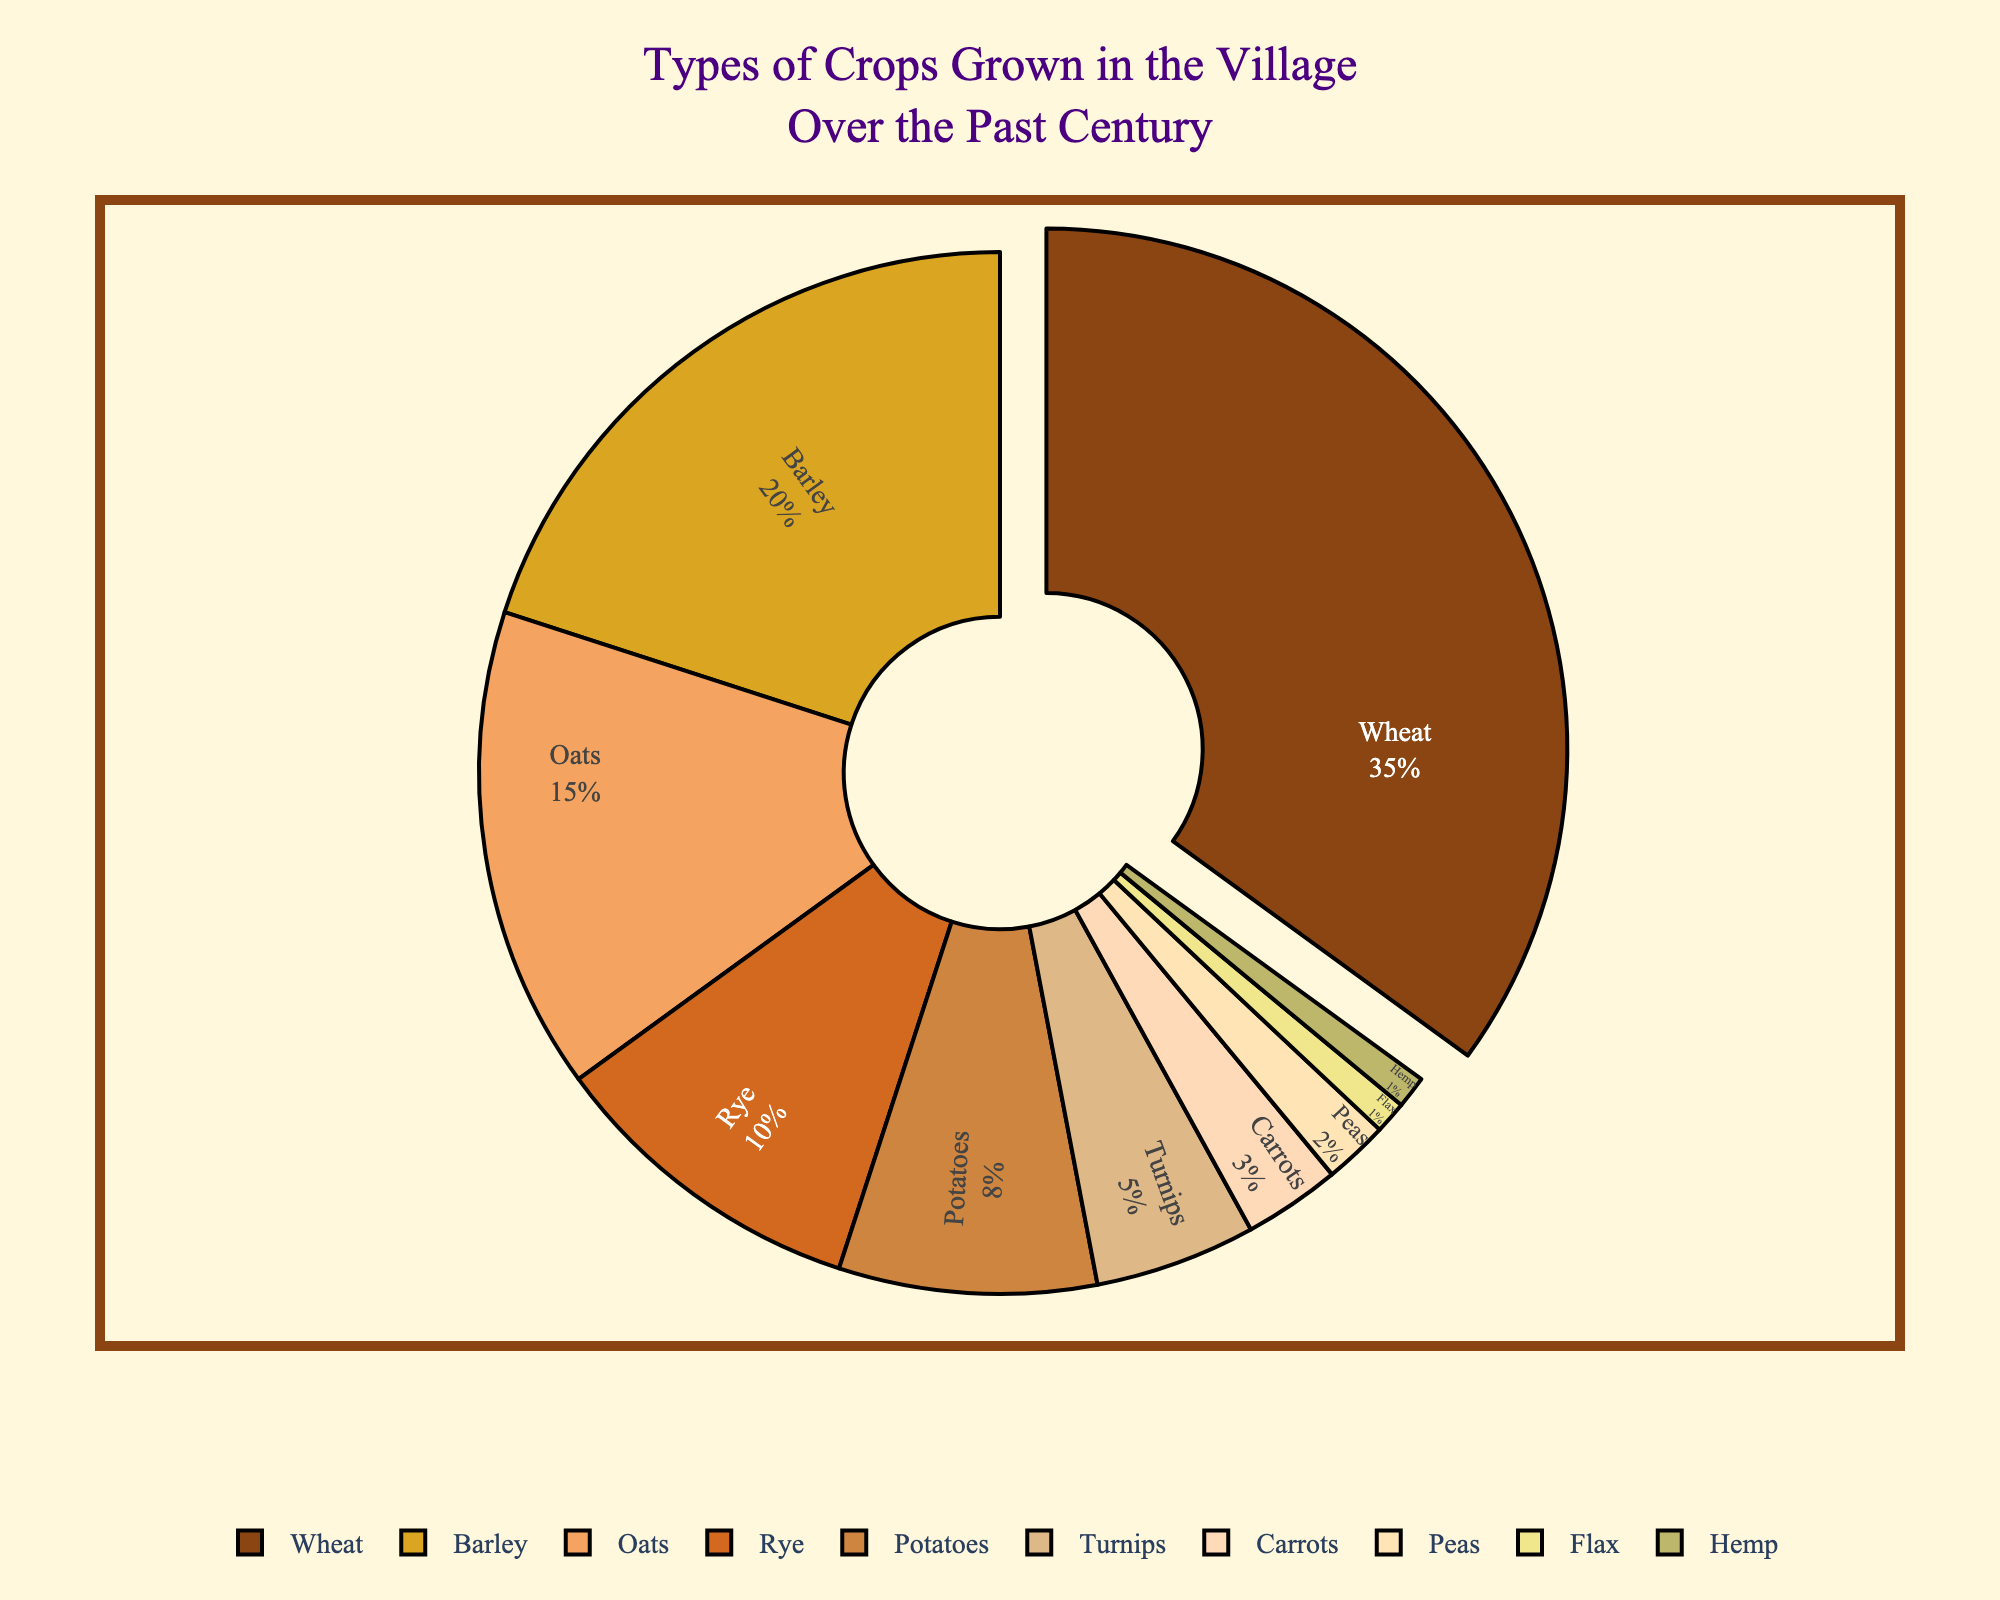Which crop has the highest percentage? Wheat has the highest percentage, which is shown both numerically (35%) and visually as the largest section in the pie chart that is slightly pulled out.
Answer: Wheat What's the difference in percentage between Wheat and Barley? Wheat is 35%, and Barley is 20%, so the difference is 35% - 20% = 15%.
Answer: 15% If we combine the percentages of Rye and Oats, what is their total percentage? Rye is 10% and Oats are 15%. To find their total percentage, we add them: 10% + 15% = 25%.
Answer: 25% Comparing Potatoes and Turnips, which crop occupies a larger portion of the pie chart? Potatoes have 8%, while Turnips have 5%. Thus, Potatoes occupy a larger portion.
Answer: Potatoes How many crops in the chart have a percentage less than 5%? Turnips have 5%, Carrots have 3%, Peas have 2%, Flax has 1%, and Hemp also has 1%. So, there are four crops with less than 5%.
Answer: 4 What is the combined percentage for crops that have 10% or more individually? Wheat is 35%, Barley is 20%, Oats are 15%, and Rye is 10%. Adding these together: 35% + 20% + 15% + 10% = 80%.
Answer: 80% Which crop appears in the lightest shade of brown on the pie chart? The color gradient shows that the lightest shade of brown is associated with Hemp.
Answer: Hemp What is the total percentage for the root crops (Potatoes, Turnips, Carrots)? Potatoes are 8%, Turnips are 5%, and Carrots are 3%. Adding these together: 8% + 5% + 3% = 16%.
Answer: 16% Is the percentage of Barley greater than the combined percentage of Peas and Flax? Barley is 20%. Peas and Flax together are 2% + 1% = 3%. 20% is indeed greater than 3%.
Answer: Yes 